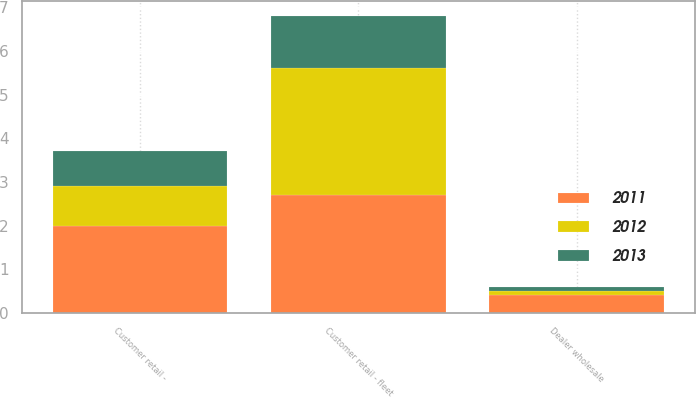<chart> <loc_0><loc_0><loc_500><loc_500><stacked_bar_chart><ecel><fcel>Dealer wholesale<fcel>Customer retail - fleet<fcel>Customer retail -<nl><fcel>2012<fcel>0.1<fcel>2.9<fcel>0.9<nl><fcel>2013<fcel>0.1<fcel>1.2<fcel>0.8<nl><fcel>2011<fcel>0.4<fcel>2.7<fcel>2<nl></chart> 